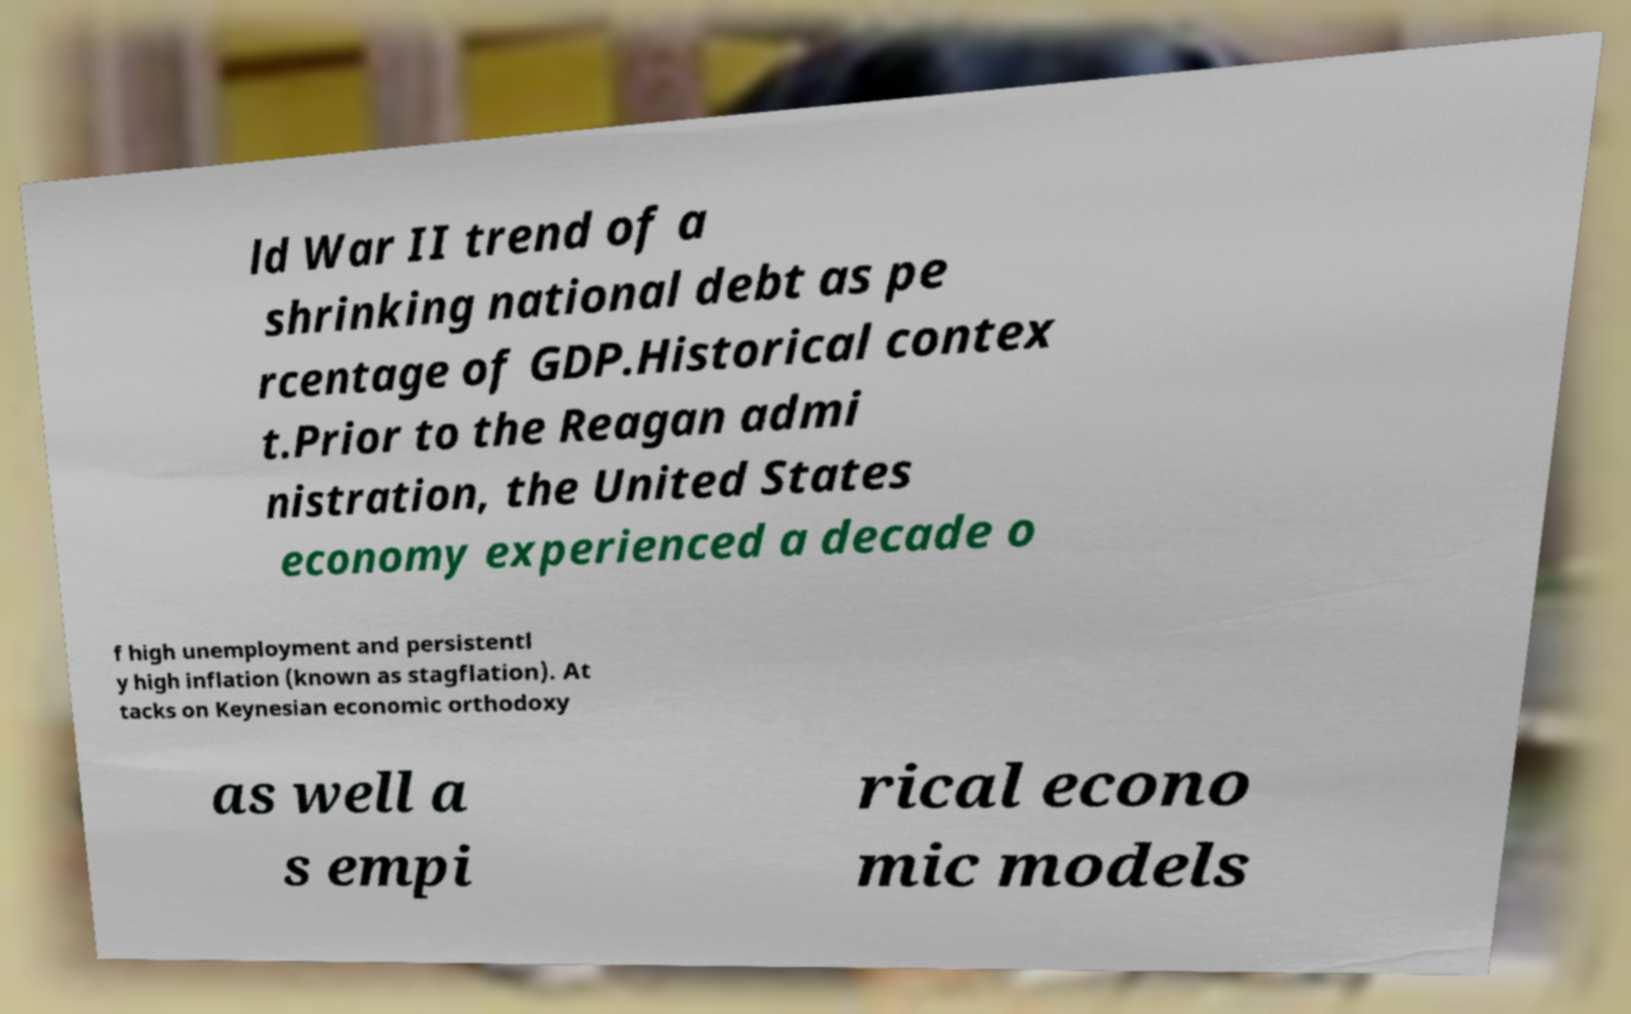Can you read and provide the text displayed in the image?This photo seems to have some interesting text. Can you extract and type it out for me? ld War II trend of a shrinking national debt as pe rcentage of GDP.Historical contex t.Prior to the Reagan admi nistration, the United States economy experienced a decade o f high unemployment and persistentl y high inflation (known as stagflation). At tacks on Keynesian economic orthodoxy as well a s empi rical econo mic models 